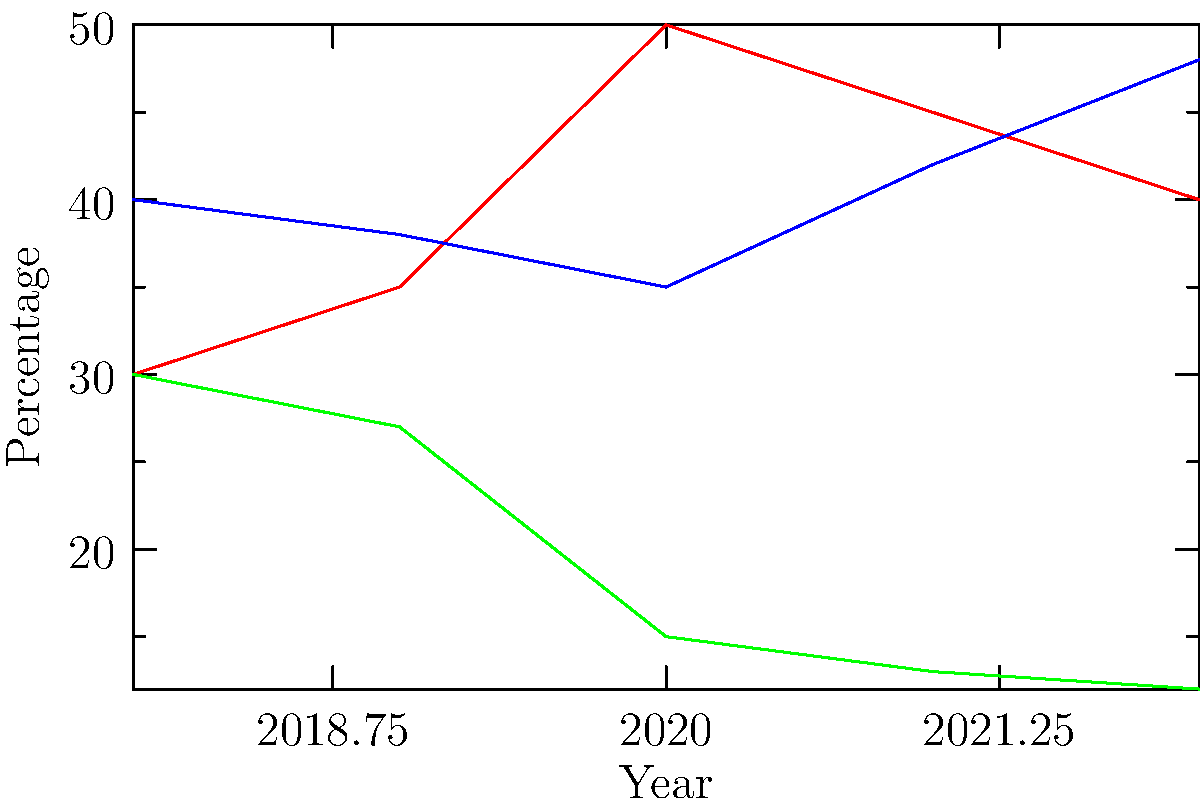As a political representative using a barber shop for informal public consultations, you've collected data on constituents' priorities over the past five years. The graph shows the percentage of people who consider each issue as their top priority. Which issue has shown the most significant change in public opinion from 2018 to 2022, and what might be a potential explanation for this trend? To answer this question, we need to analyze the trends for each issue from 2018 to 2022:

1. Healthcare:
   - 2018: 30%
   - 2022: 40%
   - Change: +10%

2. Education:
   - 2018: 40%
   - 2022: 48%
   - Change: +8%

3. Infrastructure:
   - 2018: 30%
   - 2022: 12%
   - Change: -18%

The issue with the most significant change is Infrastructure, with a decrease of 18 percentage points.

Potential explanation for this trend:
1. The graph shows a steady decline in infrastructure as a top priority from 2018 to 2022.
2. This could be due to significant improvements in local infrastructure over this period, reducing its perceived importance.
3. Alternatively, other issues like healthcare and education may have become more pressing, overshadowing infrastructure concerns.
4. The COVID-19 pandemic, which likely occurred during this timeframe, could have shifted focus towards healthcare and education, drawing attention away from infrastructure.
5. Economic factors or policy changes might have also influenced this shift in priorities.

As a political representative, this trend suggests a need to reassess the allocation of resources and attention to infrastructure projects, while also addressing the growing concerns in healthcare and education.
Answer: Infrastructure (-18%); potentially due to improvements or shift in focus to healthcare/education during pandemic. 